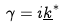<formula> <loc_0><loc_0><loc_500><loc_500>\gamma = i \underline { k } ^ { * }</formula> 